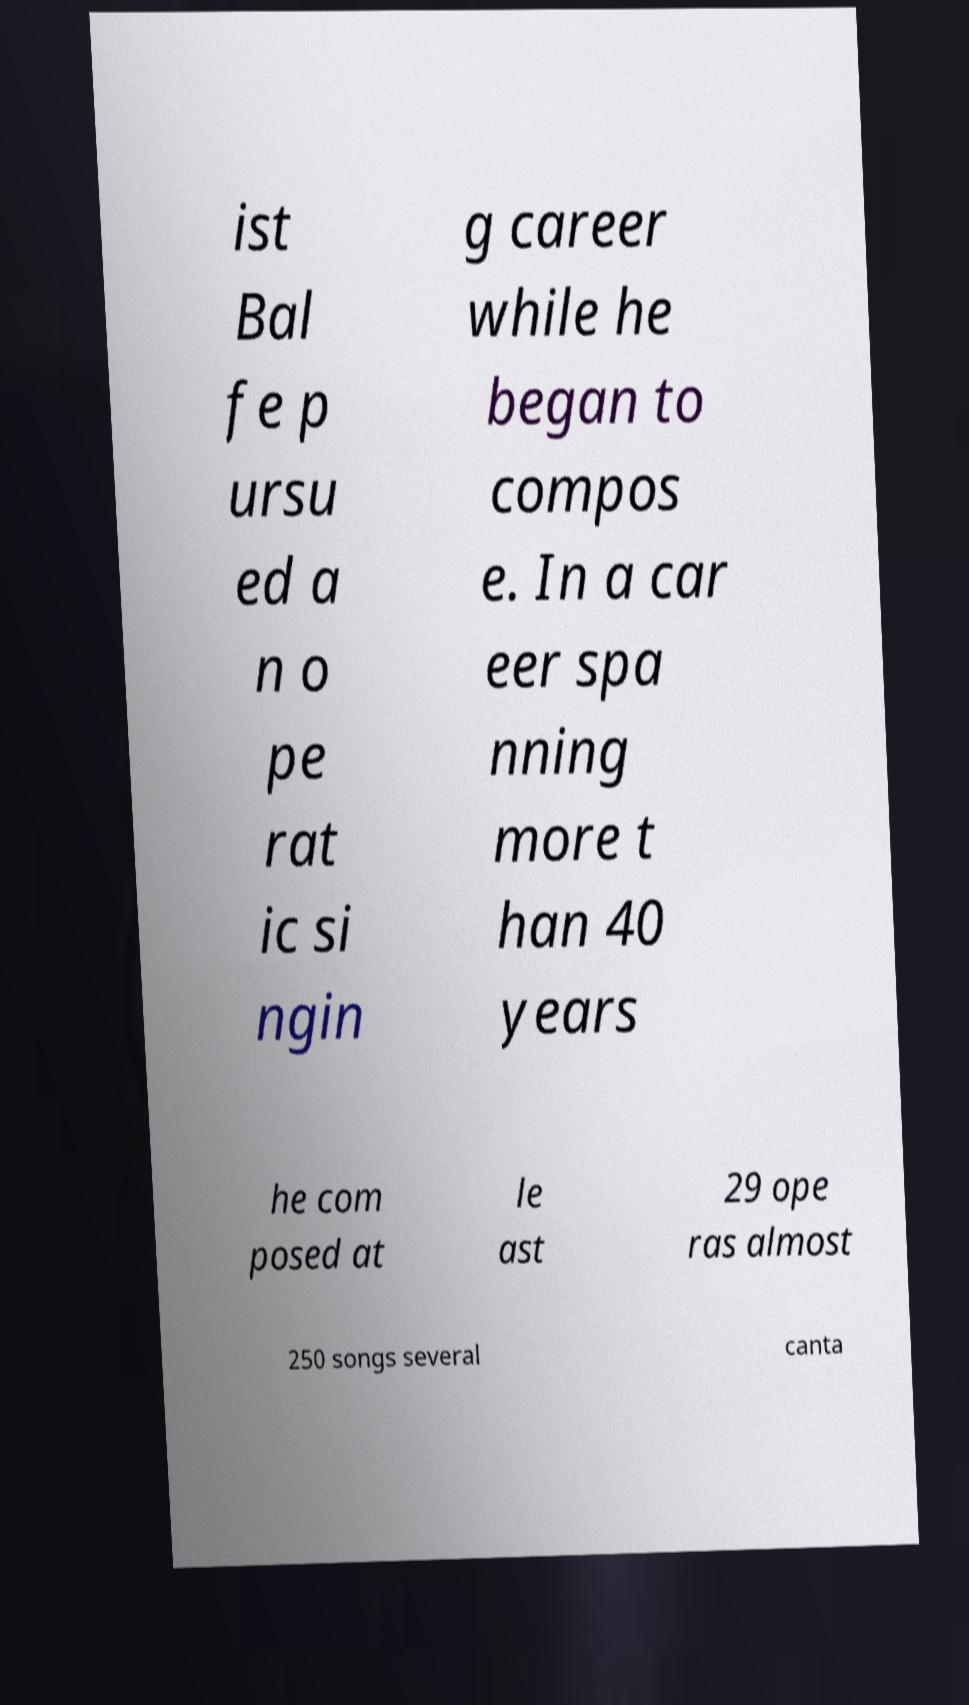Could you assist in decoding the text presented in this image and type it out clearly? ist Bal fe p ursu ed a n o pe rat ic si ngin g career while he began to compos e. In a car eer spa nning more t han 40 years he com posed at le ast 29 ope ras almost 250 songs several canta 